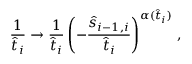<formula> <loc_0><loc_0><loc_500><loc_500>{ \frac { 1 } { \hat { t } _ { i } } } \rightarrow { \frac { 1 } { \hat { t } _ { i } } } \left ( - { \frac { \hat { s } _ { i - 1 , i } } { \hat { t } _ { i } } } \right ) ^ { \alpha ( \hat { t } _ { i } ) } \, ,</formula> 